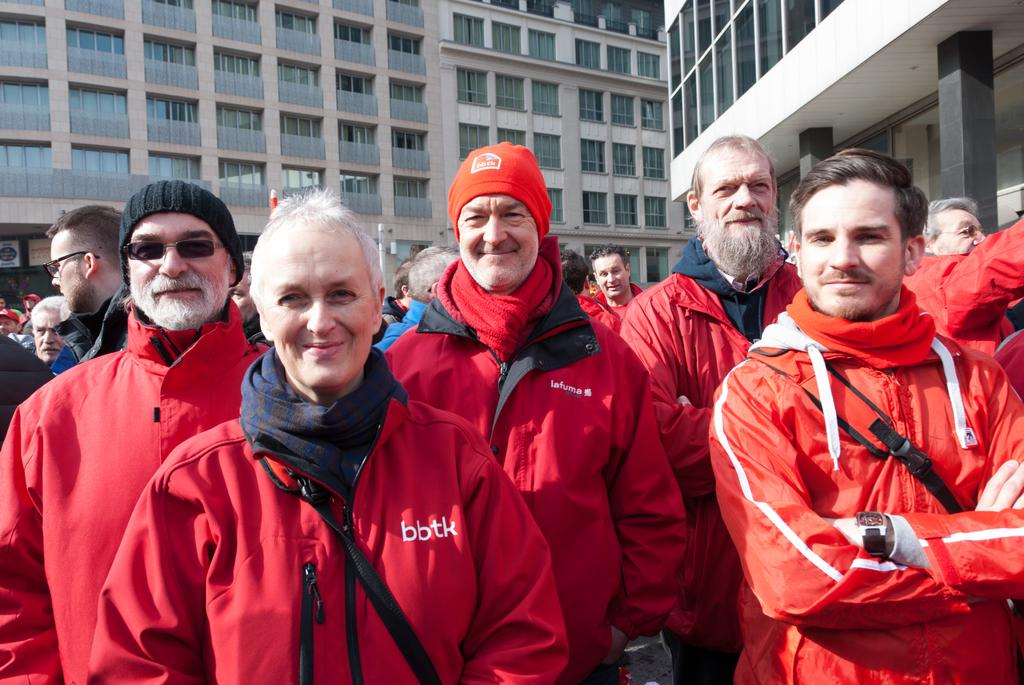Who or what can be seen in the image? There are people in the image. What are some of the people wearing? Some people are wearing red jackets. What can be seen in the distance behind the people? There are buildings and glass windows in the background of the image. What type of health advice can be seen on the people's toes in the image? There is no health advice or mention of toes in the image; it features people and buildings in the background. 